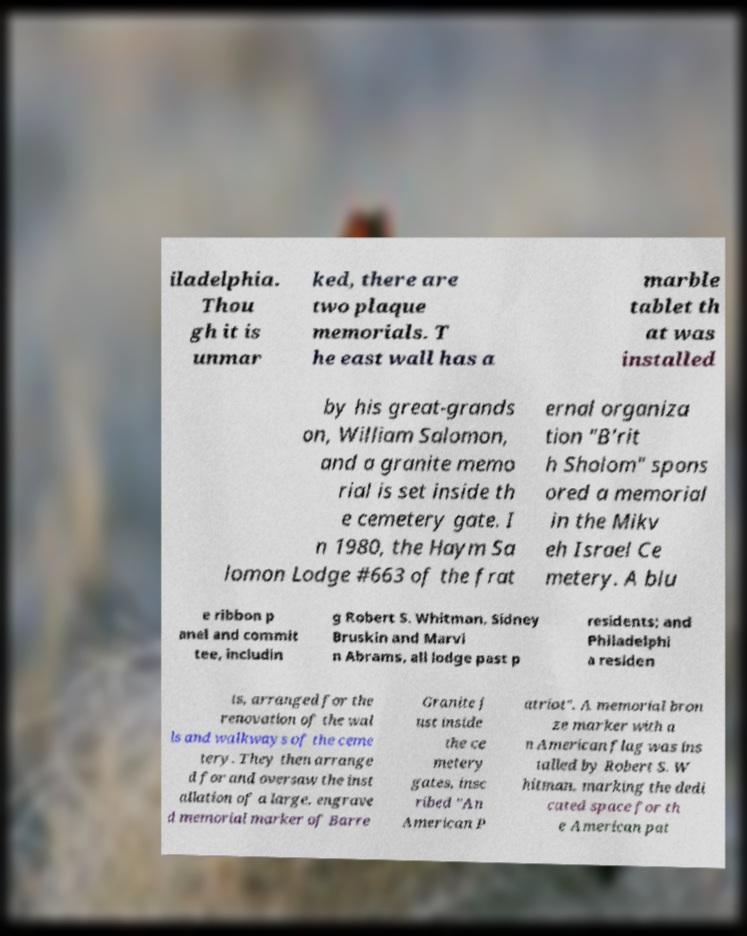Could you extract and type out the text from this image? iladelphia. Thou gh it is unmar ked, there are two plaque memorials. T he east wall has a marble tablet th at was installed by his great-grands on, William Salomon, and a granite memo rial is set inside th e cemetery gate. I n 1980, the Haym Sa lomon Lodge #663 of the frat ernal organiza tion "B'rit h Sholom" spons ored a memorial in the Mikv eh Israel Ce metery. A blu e ribbon p anel and commit tee, includin g Robert S. Whitman, Sidney Bruskin and Marvi n Abrams, all lodge past p residents; and Philadelphi a residen ts, arranged for the renovation of the wal ls and walkways of the ceme tery. They then arrange d for and oversaw the inst allation of a large, engrave d memorial marker of Barre Granite j ust inside the ce metery gates, insc ribed "An American P atriot". A memorial bron ze marker with a n American flag was ins talled by Robert S. W hitman, marking the dedi cated space for th e American pat 